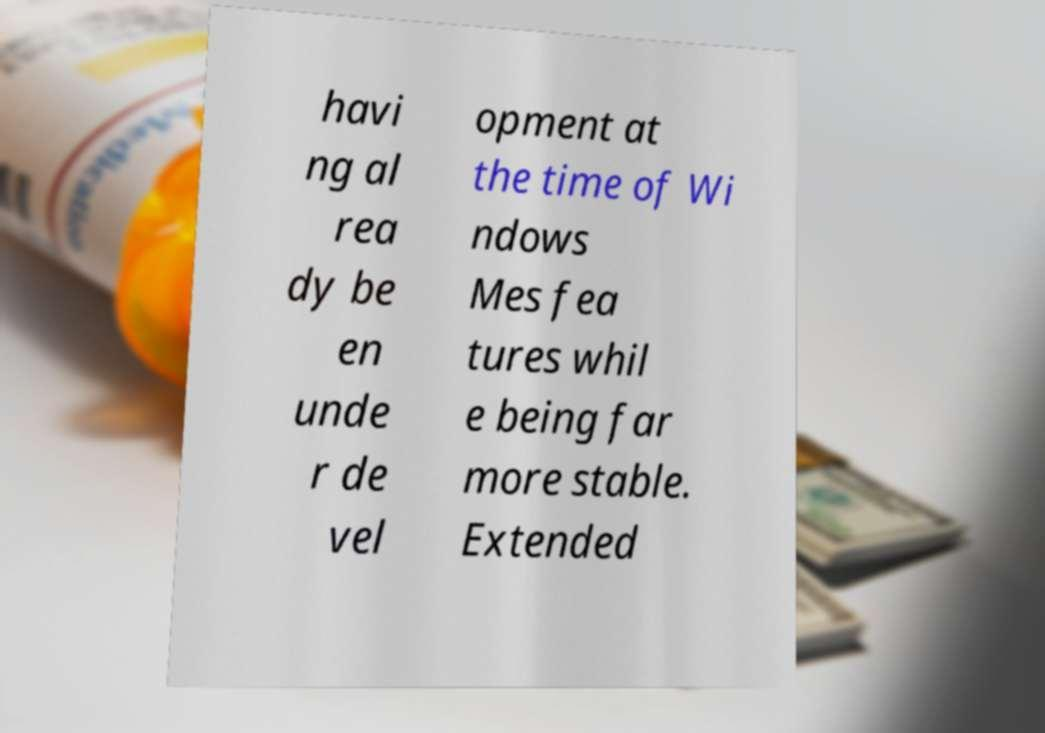For documentation purposes, I need the text within this image transcribed. Could you provide that? havi ng al rea dy be en unde r de vel opment at the time of Wi ndows Mes fea tures whil e being far more stable. Extended 